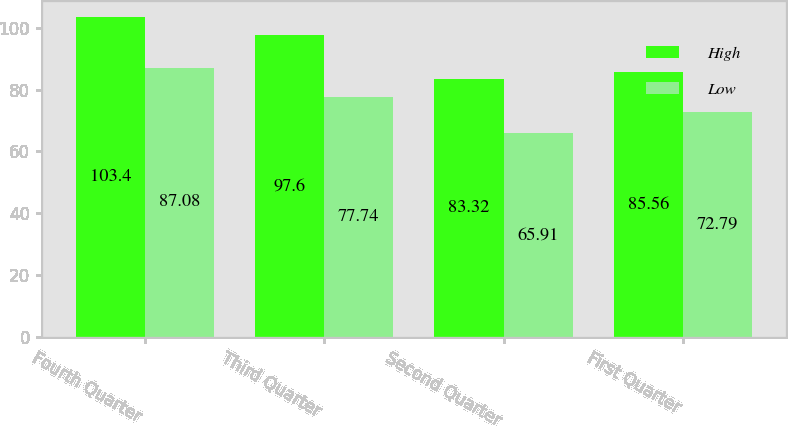Convert chart. <chart><loc_0><loc_0><loc_500><loc_500><stacked_bar_chart><ecel><fcel>Fourth Quarter<fcel>Third Quarter<fcel>Second Quarter<fcel>First Quarter<nl><fcel>High<fcel>103.4<fcel>97.6<fcel>83.32<fcel>85.56<nl><fcel>Low<fcel>87.08<fcel>77.74<fcel>65.91<fcel>72.79<nl></chart> 